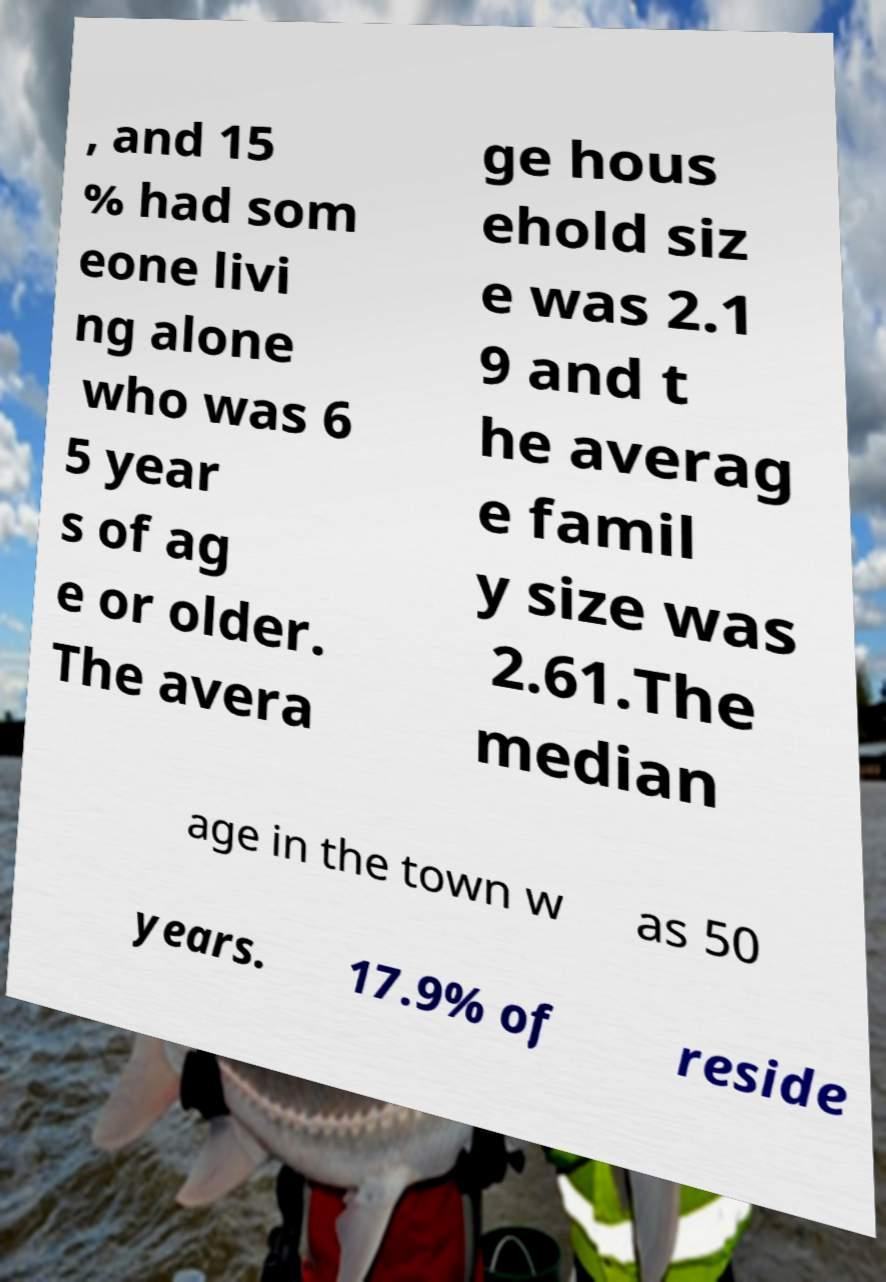I need the written content from this picture converted into text. Can you do that? , and 15 % had som eone livi ng alone who was 6 5 year s of ag e or older. The avera ge hous ehold siz e was 2.1 9 and t he averag e famil y size was 2.61.The median age in the town w as 50 years. 17.9% of reside 